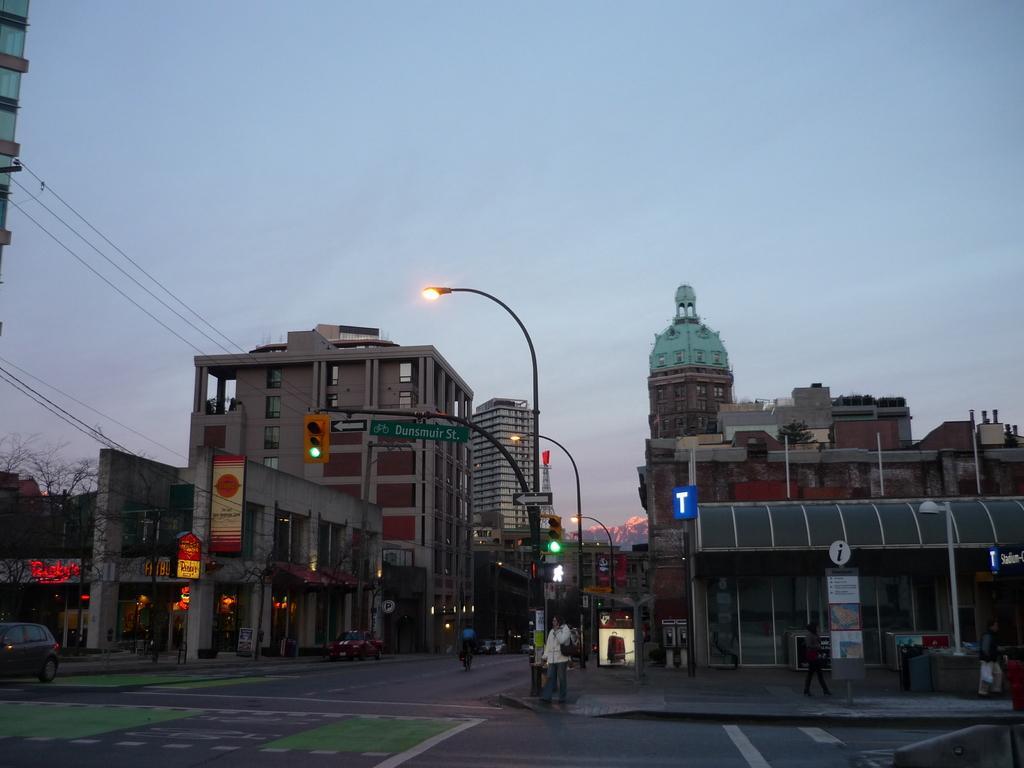Describe this image in one or two sentences. This image is clicked on the roads. There are few people in this image. To the left and right, there are buildings. In the middle, we can see a street light along with a single pole. At the top, there is a sky. At the bottom, there is a road. 